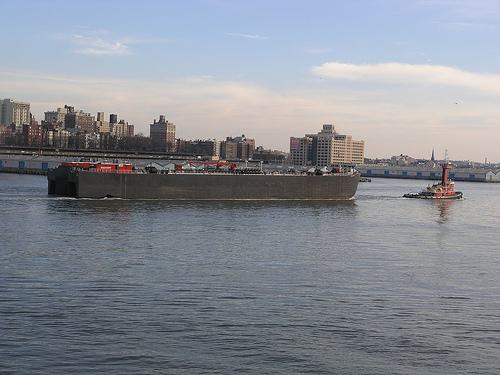What time of day does it appear to be in the image? The image suggests it's late afternoon based on the soft light and the long shadows cast, indicating the sun is on its descent towards the horizon. Does the image indicate anything about the location or setting? Yes, there are dense buildings along the skyline which suggest an urban setting. It could be a river or a bay near a city based on the infrastructure and high density of structures along the shore. 